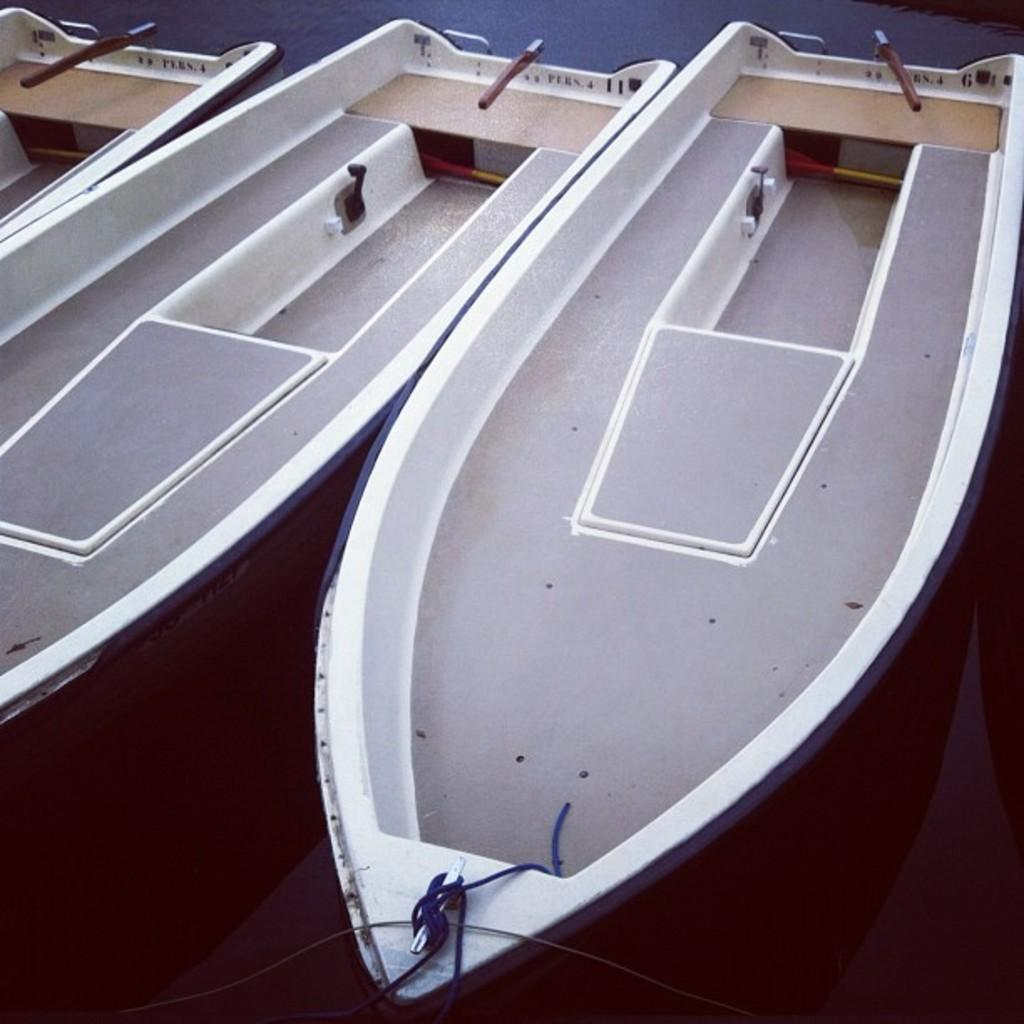What is the main subject of the image? The main subject of the image is three boats. Where are the boats located in the image? The boats are in the middle of the image. Is there any additional detail about the boats in the image? Yes, there is a rope tied to the bottom of the boats in the image. What type of ice does the queen use to cool the boats in the image? There is no queen or ice present in the image, and therefore no such activity can be observed. 